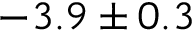Convert formula to latex. <formula><loc_0><loc_0><loc_500><loc_500>- 3 . 9 \pm 0 . 3</formula> 